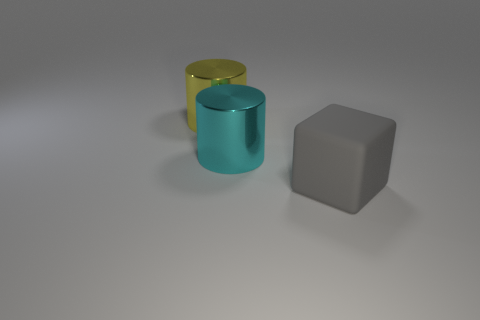Can you tell me about the lighting in this image? The lighting in the image is soft and diffused, with subtle shadows cast by the objects suggesting a light source coming from above. This lighting choice highlights the objects' colors and shapes without causing any harsh glare. 